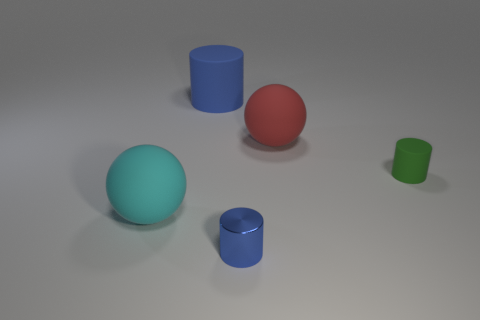There is a small object that is the same color as the large matte cylinder; what material is it?
Give a very brief answer. Metal. How many large objects are the same shape as the tiny green rubber thing?
Offer a very short reply. 1. Is the number of rubber things to the left of the green rubber thing greater than the number of big blue matte objects?
Provide a short and direct response. Yes. There is a big object that is in front of the sphere that is right of the blue object that is behind the small rubber cylinder; what shape is it?
Your answer should be compact. Sphere. Do the small object that is in front of the small green matte object and the tiny object that is behind the big cyan ball have the same shape?
Ensure brevity in your answer.  Yes. Are there any other things that have the same size as the red ball?
Your answer should be compact. Yes. How many cylinders are purple metallic things or tiny green rubber objects?
Offer a very short reply. 1. Do the cyan thing and the tiny green cylinder have the same material?
Ensure brevity in your answer.  Yes. How many other things are the same color as the small matte cylinder?
Make the answer very short. 0. What is the shape of the large cyan matte thing left of the tiny green thing?
Your answer should be compact. Sphere. 